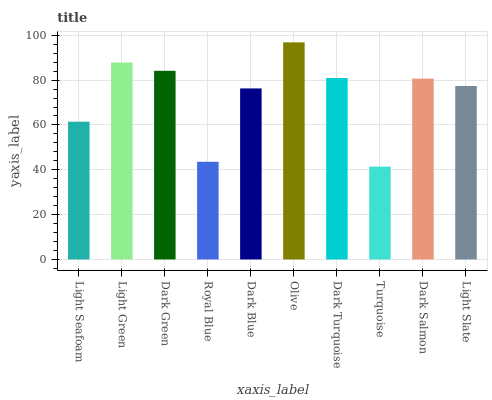Is Turquoise the minimum?
Answer yes or no. Yes. Is Olive the maximum?
Answer yes or no. Yes. Is Light Green the minimum?
Answer yes or no. No. Is Light Green the maximum?
Answer yes or no. No. Is Light Green greater than Light Seafoam?
Answer yes or no. Yes. Is Light Seafoam less than Light Green?
Answer yes or no. Yes. Is Light Seafoam greater than Light Green?
Answer yes or no. No. Is Light Green less than Light Seafoam?
Answer yes or no. No. Is Dark Salmon the high median?
Answer yes or no. Yes. Is Light Slate the low median?
Answer yes or no. Yes. Is Light Seafoam the high median?
Answer yes or no. No. Is Light Green the low median?
Answer yes or no. No. 